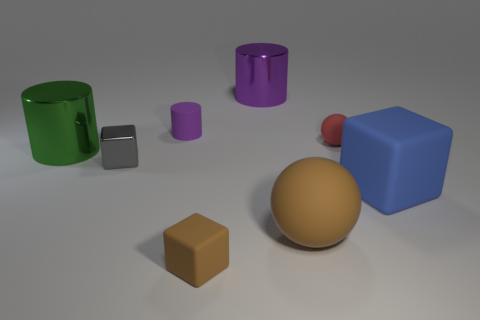The rubber thing that is the same color as the small matte cube is what size?
Offer a very short reply. Large. How many big things are on the right side of the rubber sphere in front of the big rubber block?
Ensure brevity in your answer.  1. There is a block that is the same color as the large rubber sphere; what is it made of?
Your response must be concise. Rubber. How many other things are there of the same color as the large matte cube?
Your answer should be compact. 0. What color is the rubber block behind the brown matte thing in front of the big ball?
Your answer should be very brief. Blue. Is there a rubber thing that has the same color as the big matte sphere?
Keep it short and to the point. Yes. How many rubber objects are big brown balls or small blue cylinders?
Offer a very short reply. 1. Are there any small cylinders made of the same material as the tiny brown block?
Your answer should be very brief. Yes. What number of tiny matte objects are on the right side of the large brown matte object and in front of the metal block?
Offer a very short reply. 0. Are there fewer objects that are right of the big purple metal cylinder than blue objects that are to the left of the tiny rubber block?
Provide a succinct answer. No. 